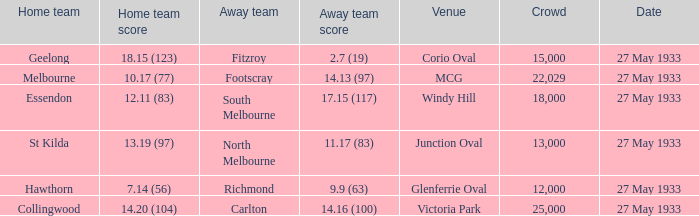During st kilda's home match, what was the quantity of individuals in the audience? 13000.0. 